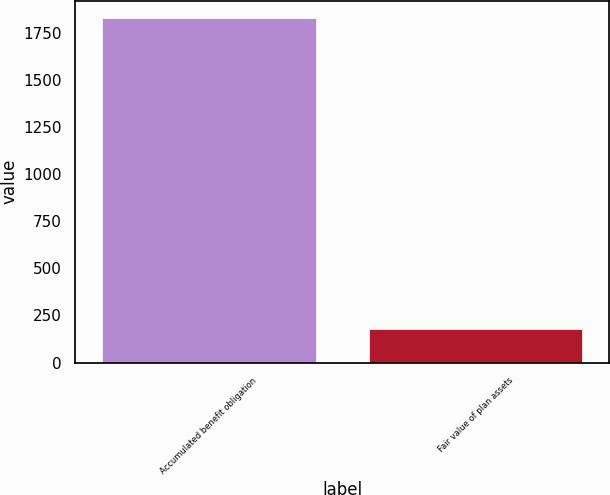<chart> <loc_0><loc_0><loc_500><loc_500><bar_chart><fcel>Accumulated benefit obligation<fcel>Fair value of plan assets<nl><fcel>1829<fcel>177<nl></chart> 